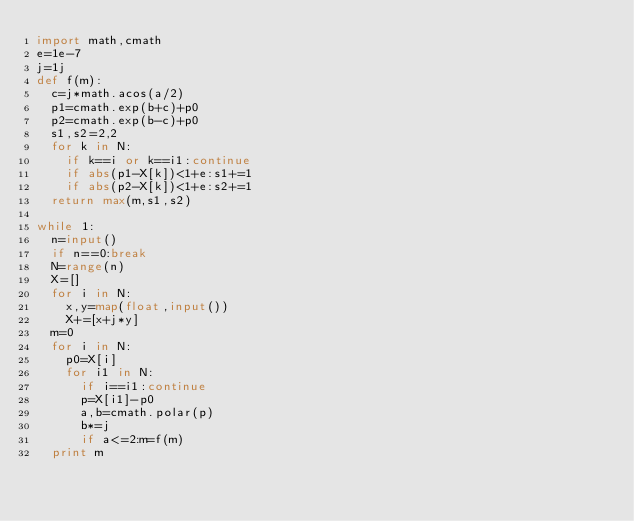Convert code to text. <code><loc_0><loc_0><loc_500><loc_500><_Python_>import math,cmath
e=1e-7
j=1j
def f(m):
  c=j*math.acos(a/2)
  p1=cmath.exp(b+c)+p0
  p2=cmath.exp(b-c)+p0
  s1,s2=2,2
  for k in N:
    if k==i or k==i1:continue
    if abs(p1-X[k])<1+e:s1+=1
    if abs(p2-X[k])<1+e:s2+=1
  return max(m,s1,s2)

while 1:
  n=input()
  if n==0:break
  N=range(n)
  X=[]
  for i in N:
    x,y=map(float,input())
    X+=[x+j*y]
  m=0
  for i in N:
    p0=X[i]
    for i1 in N:
      if i==i1:continue
      p=X[i1]-p0
      a,b=cmath.polar(p)
      b*=j
      if a<=2:m=f(m)
  print m</code> 